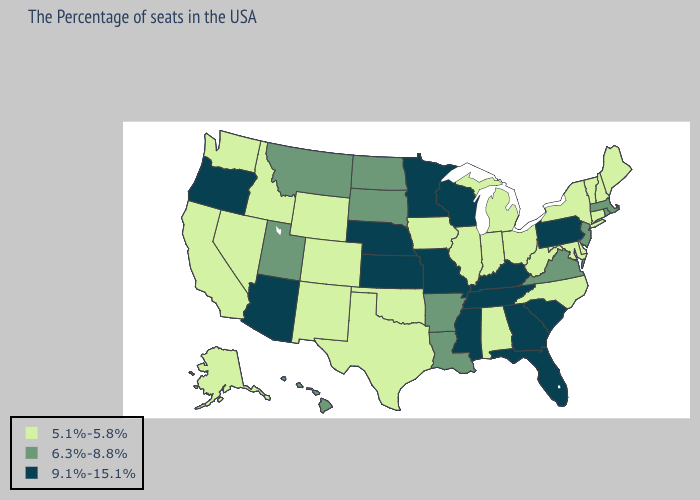Does Michigan have the highest value in the MidWest?
Short answer required. No. What is the highest value in the MidWest ?
Write a very short answer. 9.1%-15.1%. Name the states that have a value in the range 5.1%-5.8%?
Keep it brief. Maine, New Hampshire, Vermont, Connecticut, New York, Delaware, Maryland, North Carolina, West Virginia, Ohio, Michigan, Indiana, Alabama, Illinois, Iowa, Oklahoma, Texas, Wyoming, Colorado, New Mexico, Idaho, Nevada, California, Washington, Alaska. Among the states that border Pennsylvania , does West Virginia have the highest value?
Give a very brief answer. No. Does New York have the lowest value in the Northeast?
Concise answer only. Yes. What is the value of Kansas?
Concise answer only. 9.1%-15.1%. What is the value of Massachusetts?
Answer briefly. 6.3%-8.8%. Among the states that border Indiana , does Illinois have the highest value?
Quick response, please. No. Does Arkansas have the same value as Delaware?
Quick response, please. No. Among the states that border Michigan , does Indiana have the highest value?
Answer briefly. No. What is the value of Oklahoma?
Keep it brief. 5.1%-5.8%. What is the lowest value in the South?
Concise answer only. 5.1%-5.8%. Name the states that have a value in the range 5.1%-5.8%?
Keep it brief. Maine, New Hampshire, Vermont, Connecticut, New York, Delaware, Maryland, North Carolina, West Virginia, Ohio, Michigan, Indiana, Alabama, Illinois, Iowa, Oklahoma, Texas, Wyoming, Colorado, New Mexico, Idaho, Nevada, California, Washington, Alaska. Among the states that border Florida , which have the lowest value?
Write a very short answer. Alabama. Which states hav the highest value in the Northeast?
Be succinct. Pennsylvania. 